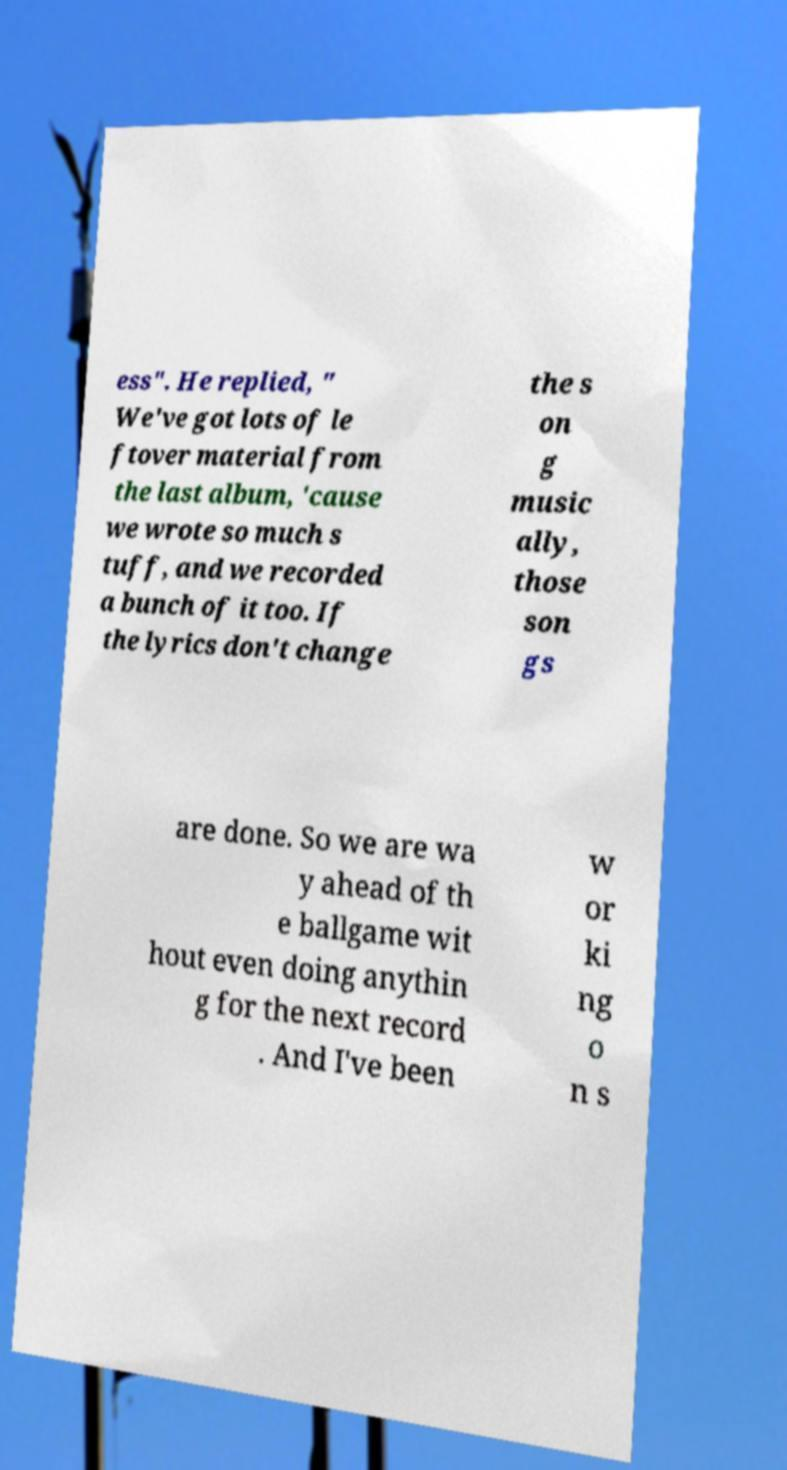For documentation purposes, I need the text within this image transcribed. Could you provide that? ess". He replied, " We've got lots of le ftover material from the last album, 'cause we wrote so much s tuff, and we recorded a bunch of it too. If the lyrics don't change the s on g music ally, those son gs are done. So we are wa y ahead of th e ballgame wit hout even doing anythin g for the next record . And I've been w or ki ng o n s 